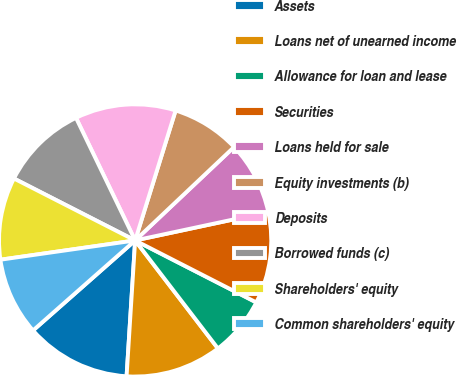Convert chart. <chart><loc_0><loc_0><loc_500><loc_500><pie_chart><fcel>Assets<fcel>Loans net of unearned income<fcel>Allowance for loan and lease<fcel>Securities<fcel>Loans held for sale<fcel>Equity investments (b)<fcel>Deposits<fcel>Borrowed funds (c)<fcel>Shareholders' equity<fcel>Common shareholders' equity<nl><fcel>12.5%<fcel>11.41%<fcel>7.07%<fcel>10.87%<fcel>8.7%<fcel>8.15%<fcel>11.96%<fcel>10.33%<fcel>9.78%<fcel>9.24%<nl></chart> 